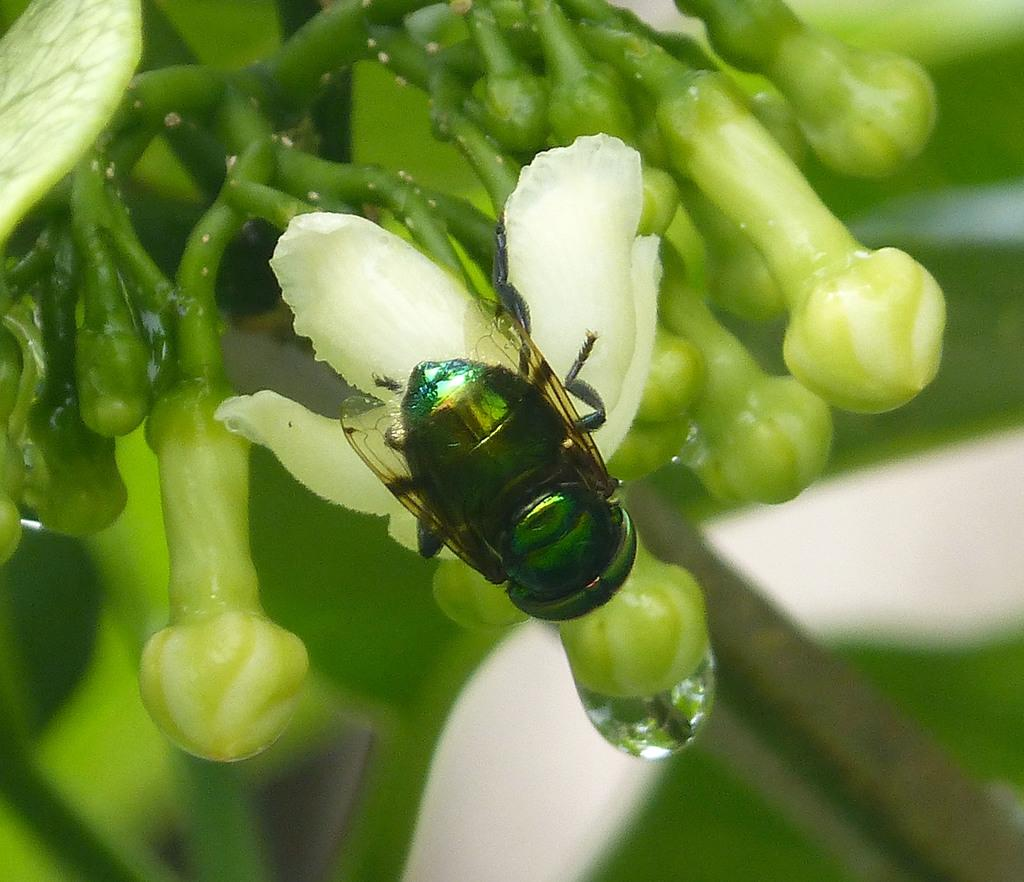What insect is present on the flower in the image? There is a house fly on a flower in the image. What stage of development are the flowers in the image? There are flower buds on the stem in the image. What can be seen on the petals of the flower? There is a water drop visible in the image. How would you describe the background of the image? The background of the image appears blurry. What type of orange is being exchanged between the expert and the house fly in the image? There is no orange or expert present in the image; it features a house fly on a flower with a water drop. 